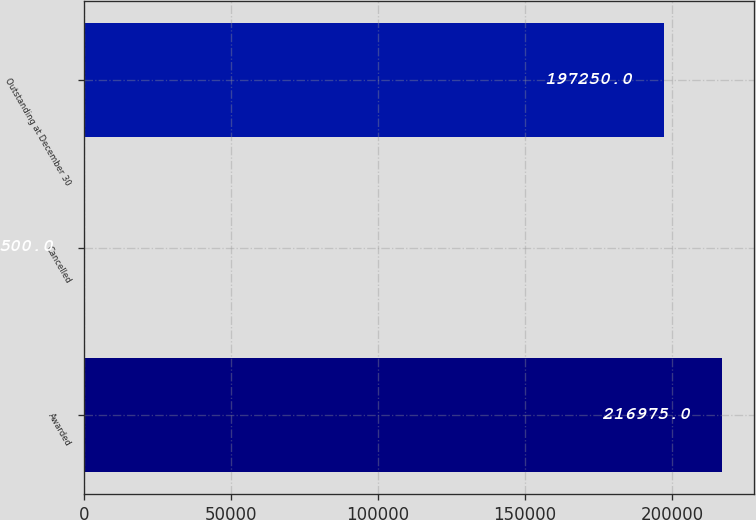Convert chart. <chart><loc_0><loc_0><loc_500><loc_500><bar_chart><fcel>Awarded<fcel>Cancelled<fcel>Outstanding at December 30<nl><fcel>216975<fcel>500<fcel>197250<nl></chart> 